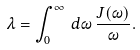Convert formula to latex. <formula><loc_0><loc_0><loc_500><loc_500>\lambda = \int _ { 0 } ^ { \infty } \, d \omega \, \frac { J ( \omega ) } { \omega } .</formula> 